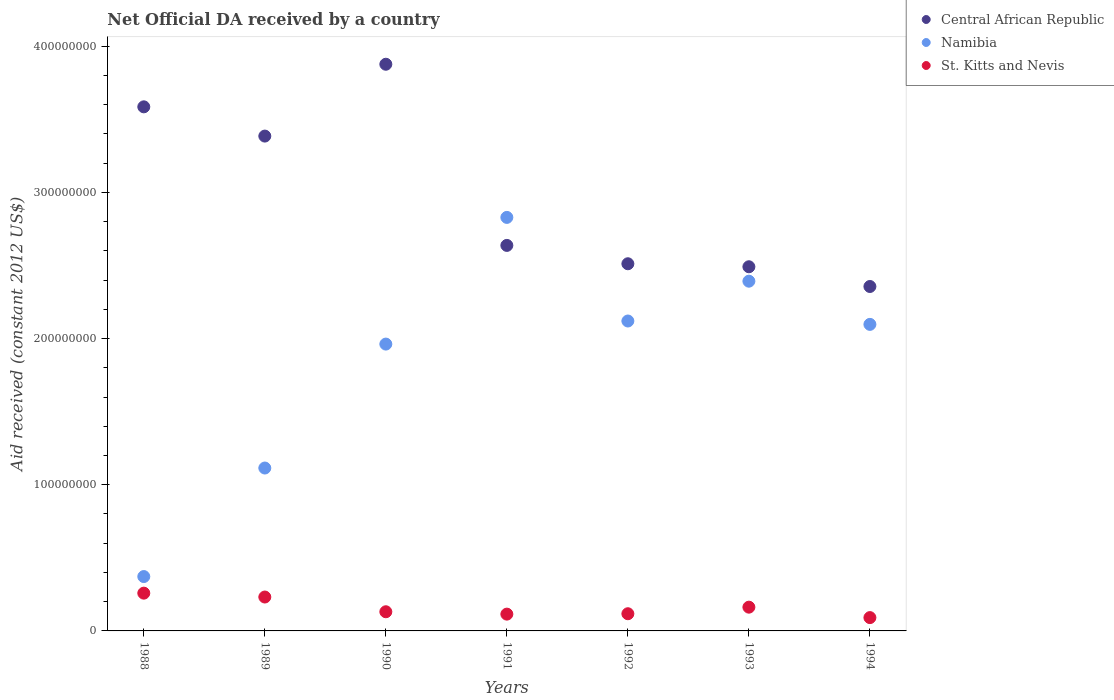Is the number of dotlines equal to the number of legend labels?
Your answer should be very brief. Yes. What is the net official development assistance aid received in Central African Republic in 1989?
Offer a very short reply. 3.39e+08. Across all years, what is the maximum net official development assistance aid received in Namibia?
Keep it short and to the point. 2.83e+08. Across all years, what is the minimum net official development assistance aid received in Central African Republic?
Offer a terse response. 2.36e+08. In which year was the net official development assistance aid received in Central African Republic minimum?
Make the answer very short. 1994. What is the total net official development assistance aid received in Namibia in the graph?
Offer a very short reply. 1.29e+09. What is the difference between the net official development assistance aid received in Namibia in 1989 and that in 1992?
Your answer should be very brief. -1.01e+08. What is the difference between the net official development assistance aid received in St. Kitts and Nevis in 1988 and the net official development assistance aid received in Central African Republic in 1992?
Offer a very short reply. -2.25e+08. What is the average net official development assistance aid received in Namibia per year?
Your answer should be very brief. 1.84e+08. In the year 1992, what is the difference between the net official development assistance aid received in St. Kitts and Nevis and net official development assistance aid received in Central African Republic?
Make the answer very short. -2.39e+08. In how many years, is the net official development assistance aid received in Central African Republic greater than 60000000 US$?
Give a very brief answer. 7. What is the ratio of the net official development assistance aid received in Central African Republic in 1988 to that in 1990?
Offer a terse response. 0.92. Is the net official development assistance aid received in Namibia in 1988 less than that in 1991?
Ensure brevity in your answer.  Yes. Is the difference between the net official development assistance aid received in St. Kitts and Nevis in 1988 and 1991 greater than the difference between the net official development assistance aid received in Central African Republic in 1988 and 1991?
Give a very brief answer. No. What is the difference between the highest and the second highest net official development assistance aid received in St. Kitts and Nevis?
Provide a succinct answer. 2.65e+06. What is the difference between the highest and the lowest net official development assistance aid received in Namibia?
Your answer should be very brief. 2.46e+08. Does the net official development assistance aid received in Namibia monotonically increase over the years?
Your response must be concise. No. Is the net official development assistance aid received in Namibia strictly greater than the net official development assistance aid received in Central African Republic over the years?
Provide a short and direct response. No. How many dotlines are there?
Provide a succinct answer. 3. How many years are there in the graph?
Provide a succinct answer. 7. Are the values on the major ticks of Y-axis written in scientific E-notation?
Your answer should be very brief. No. Does the graph contain any zero values?
Make the answer very short. No. Where does the legend appear in the graph?
Your answer should be very brief. Top right. How many legend labels are there?
Give a very brief answer. 3. How are the legend labels stacked?
Ensure brevity in your answer.  Vertical. What is the title of the graph?
Keep it short and to the point. Net Official DA received by a country. What is the label or title of the Y-axis?
Keep it short and to the point. Aid received (constant 2012 US$). What is the Aid received (constant 2012 US$) in Central African Republic in 1988?
Offer a terse response. 3.59e+08. What is the Aid received (constant 2012 US$) in Namibia in 1988?
Your answer should be compact. 3.72e+07. What is the Aid received (constant 2012 US$) in St. Kitts and Nevis in 1988?
Provide a short and direct response. 2.58e+07. What is the Aid received (constant 2012 US$) in Central African Republic in 1989?
Provide a short and direct response. 3.39e+08. What is the Aid received (constant 2012 US$) of Namibia in 1989?
Provide a succinct answer. 1.11e+08. What is the Aid received (constant 2012 US$) in St. Kitts and Nevis in 1989?
Offer a terse response. 2.32e+07. What is the Aid received (constant 2012 US$) in Central African Republic in 1990?
Provide a short and direct response. 3.88e+08. What is the Aid received (constant 2012 US$) in Namibia in 1990?
Offer a very short reply. 1.96e+08. What is the Aid received (constant 2012 US$) in St. Kitts and Nevis in 1990?
Your answer should be very brief. 1.31e+07. What is the Aid received (constant 2012 US$) of Central African Republic in 1991?
Provide a short and direct response. 2.64e+08. What is the Aid received (constant 2012 US$) of Namibia in 1991?
Your response must be concise. 2.83e+08. What is the Aid received (constant 2012 US$) of St. Kitts and Nevis in 1991?
Keep it short and to the point. 1.15e+07. What is the Aid received (constant 2012 US$) of Central African Republic in 1992?
Ensure brevity in your answer.  2.51e+08. What is the Aid received (constant 2012 US$) of Namibia in 1992?
Your answer should be very brief. 2.12e+08. What is the Aid received (constant 2012 US$) in St. Kitts and Nevis in 1992?
Provide a succinct answer. 1.18e+07. What is the Aid received (constant 2012 US$) of Central African Republic in 1993?
Your response must be concise. 2.49e+08. What is the Aid received (constant 2012 US$) of Namibia in 1993?
Provide a succinct answer. 2.39e+08. What is the Aid received (constant 2012 US$) of St. Kitts and Nevis in 1993?
Keep it short and to the point. 1.62e+07. What is the Aid received (constant 2012 US$) of Central African Republic in 1994?
Offer a very short reply. 2.36e+08. What is the Aid received (constant 2012 US$) of Namibia in 1994?
Give a very brief answer. 2.10e+08. What is the Aid received (constant 2012 US$) in St. Kitts and Nevis in 1994?
Your response must be concise. 9.11e+06. Across all years, what is the maximum Aid received (constant 2012 US$) of Central African Republic?
Your answer should be compact. 3.88e+08. Across all years, what is the maximum Aid received (constant 2012 US$) of Namibia?
Keep it short and to the point. 2.83e+08. Across all years, what is the maximum Aid received (constant 2012 US$) of St. Kitts and Nevis?
Ensure brevity in your answer.  2.58e+07. Across all years, what is the minimum Aid received (constant 2012 US$) of Central African Republic?
Make the answer very short. 2.36e+08. Across all years, what is the minimum Aid received (constant 2012 US$) of Namibia?
Provide a short and direct response. 3.72e+07. Across all years, what is the minimum Aid received (constant 2012 US$) in St. Kitts and Nevis?
Offer a very short reply. 9.11e+06. What is the total Aid received (constant 2012 US$) of Central African Republic in the graph?
Provide a succinct answer. 2.08e+09. What is the total Aid received (constant 2012 US$) in Namibia in the graph?
Your answer should be very brief. 1.29e+09. What is the total Aid received (constant 2012 US$) in St. Kitts and Nevis in the graph?
Your answer should be very brief. 1.11e+08. What is the difference between the Aid received (constant 2012 US$) in Central African Republic in 1988 and that in 1989?
Provide a succinct answer. 2.00e+07. What is the difference between the Aid received (constant 2012 US$) in Namibia in 1988 and that in 1989?
Your response must be concise. -7.43e+07. What is the difference between the Aid received (constant 2012 US$) of St. Kitts and Nevis in 1988 and that in 1989?
Give a very brief answer. 2.65e+06. What is the difference between the Aid received (constant 2012 US$) of Central African Republic in 1988 and that in 1990?
Keep it short and to the point. -2.91e+07. What is the difference between the Aid received (constant 2012 US$) of Namibia in 1988 and that in 1990?
Offer a terse response. -1.59e+08. What is the difference between the Aid received (constant 2012 US$) of St. Kitts and Nevis in 1988 and that in 1990?
Keep it short and to the point. 1.27e+07. What is the difference between the Aid received (constant 2012 US$) of Central African Republic in 1988 and that in 1991?
Make the answer very short. 9.48e+07. What is the difference between the Aid received (constant 2012 US$) in Namibia in 1988 and that in 1991?
Ensure brevity in your answer.  -2.46e+08. What is the difference between the Aid received (constant 2012 US$) of St. Kitts and Nevis in 1988 and that in 1991?
Ensure brevity in your answer.  1.44e+07. What is the difference between the Aid received (constant 2012 US$) of Central African Republic in 1988 and that in 1992?
Give a very brief answer. 1.07e+08. What is the difference between the Aid received (constant 2012 US$) in Namibia in 1988 and that in 1992?
Your answer should be compact. -1.75e+08. What is the difference between the Aid received (constant 2012 US$) of St. Kitts and Nevis in 1988 and that in 1992?
Give a very brief answer. 1.41e+07. What is the difference between the Aid received (constant 2012 US$) in Central African Republic in 1988 and that in 1993?
Offer a terse response. 1.09e+08. What is the difference between the Aid received (constant 2012 US$) of Namibia in 1988 and that in 1993?
Your answer should be very brief. -2.02e+08. What is the difference between the Aid received (constant 2012 US$) in St. Kitts and Nevis in 1988 and that in 1993?
Your answer should be compact. 9.59e+06. What is the difference between the Aid received (constant 2012 US$) of Central African Republic in 1988 and that in 1994?
Offer a terse response. 1.23e+08. What is the difference between the Aid received (constant 2012 US$) of Namibia in 1988 and that in 1994?
Offer a very short reply. -1.73e+08. What is the difference between the Aid received (constant 2012 US$) of St. Kitts and Nevis in 1988 and that in 1994?
Your answer should be compact. 1.67e+07. What is the difference between the Aid received (constant 2012 US$) in Central African Republic in 1989 and that in 1990?
Offer a very short reply. -4.92e+07. What is the difference between the Aid received (constant 2012 US$) in Namibia in 1989 and that in 1990?
Provide a short and direct response. -8.48e+07. What is the difference between the Aid received (constant 2012 US$) in St. Kitts and Nevis in 1989 and that in 1990?
Provide a short and direct response. 1.01e+07. What is the difference between the Aid received (constant 2012 US$) of Central African Republic in 1989 and that in 1991?
Offer a terse response. 7.48e+07. What is the difference between the Aid received (constant 2012 US$) in Namibia in 1989 and that in 1991?
Provide a short and direct response. -1.71e+08. What is the difference between the Aid received (constant 2012 US$) in St. Kitts and Nevis in 1989 and that in 1991?
Make the answer very short. 1.17e+07. What is the difference between the Aid received (constant 2012 US$) of Central African Republic in 1989 and that in 1992?
Offer a very short reply. 8.74e+07. What is the difference between the Aid received (constant 2012 US$) in Namibia in 1989 and that in 1992?
Your answer should be compact. -1.01e+08. What is the difference between the Aid received (constant 2012 US$) in St. Kitts and Nevis in 1989 and that in 1992?
Provide a short and direct response. 1.14e+07. What is the difference between the Aid received (constant 2012 US$) of Central African Republic in 1989 and that in 1993?
Provide a succinct answer. 8.94e+07. What is the difference between the Aid received (constant 2012 US$) in Namibia in 1989 and that in 1993?
Provide a short and direct response. -1.28e+08. What is the difference between the Aid received (constant 2012 US$) of St. Kitts and Nevis in 1989 and that in 1993?
Offer a very short reply. 6.94e+06. What is the difference between the Aid received (constant 2012 US$) of Central African Republic in 1989 and that in 1994?
Offer a terse response. 1.03e+08. What is the difference between the Aid received (constant 2012 US$) in Namibia in 1989 and that in 1994?
Your response must be concise. -9.83e+07. What is the difference between the Aid received (constant 2012 US$) of St. Kitts and Nevis in 1989 and that in 1994?
Keep it short and to the point. 1.41e+07. What is the difference between the Aid received (constant 2012 US$) of Central African Republic in 1990 and that in 1991?
Ensure brevity in your answer.  1.24e+08. What is the difference between the Aid received (constant 2012 US$) of Namibia in 1990 and that in 1991?
Your answer should be compact. -8.67e+07. What is the difference between the Aid received (constant 2012 US$) in St. Kitts and Nevis in 1990 and that in 1991?
Provide a succinct answer. 1.62e+06. What is the difference between the Aid received (constant 2012 US$) of Central African Republic in 1990 and that in 1992?
Your answer should be very brief. 1.36e+08. What is the difference between the Aid received (constant 2012 US$) of Namibia in 1990 and that in 1992?
Offer a very short reply. -1.58e+07. What is the difference between the Aid received (constant 2012 US$) of St. Kitts and Nevis in 1990 and that in 1992?
Offer a terse response. 1.35e+06. What is the difference between the Aid received (constant 2012 US$) in Central African Republic in 1990 and that in 1993?
Your answer should be compact. 1.39e+08. What is the difference between the Aid received (constant 2012 US$) of Namibia in 1990 and that in 1993?
Your response must be concise. -4.30e+07. What is the difference between the Aid received (constant 2012 US$) in St. Kitts and Nevis in 1990 and that in 1993?
Give a very brief answer. -3.14e+06. What is the difference between the Aid received (constant 2012 US$) in Central African Republic in 1990 and that in 1994?
Offer a terse response. 1.52e+08. What is the difference between the Aid received (constant 2012 US$) in Namibia in 1990 and that in 1994?
Keep it short and to the point. -1.35e+07. What is the difference between the Aid received (constant 2012 US$) of St. Kitts and Nevis in 1990 and that in 1994?
Keep it short and to the point. 4.00e+06. What is the difference between the Aid received (constant 2012 US$) of Central African Republic in 1991 and that in 1992?
Your response must be concise. 1.26e+07. What is the difference between the Aid received (constant 2012 US$) of Namibia in 1991 and that in 1992?
Give a very brief answer. 7.09e+07. What is the difference between the Aid received (constant 2012 US$) in Central African Republic in 1991 and that in 1993?
Provide a short and direct response. 1.46e+07. What is the difference between the Aid received (constant 2012 US$) in Namibia in 1991 and that in 1993?
Offer a terse response. 4.36e+07. What is the difference between the Aid received (constant 2012 US$) of St. Kitts and Nevis in 1991 and that in 1993?
Your answer should be very brief. -4.76e+06. What is the difference between the Aid received (constant 2012 US$) in Central African Republic in 1991 and that in 1994?
Your response must be concise. 2.81e+07. What is the difference between the Aid received (constant 2012 US$) of Namibia in 1991 and that in 1994?
Ensure brevity in your answer.  7.32e+07. What is the difference between the Aid received (constant 2012 US$) in St. Kitts and Nevis in 1991 and that in 1994?
Keep it short and to the point. 2.38e+06. What is the difference between the Aid received (constant 2012 US$) of Central African Republic in 1992 and that in 1993?
Keep it short and to the point. 2.06e+06. What is the difference between the Aid received (constant 2012 US$) in Namibia in 1992 and that in 1993?
Offer a terse response. -2.72e+07. What is the difference between the Aid received (constant 2012 US$) of St. Kitts and Nevis in 1992 and that in 1993?
Your answer should be very brief. -4.49e+06. What is the difference between the Aid received (constant 2012 US$) in Central African Republic in 1992 and that in 1994?
Keep it short and to the point. 1.56e+07. What is the difference between the Aid received (constant 2012 US$) in Namibia in 1992 and that in 1994?
Offer a terse response. 2.31e+06. What is the difference between the Aid received (constant 2012 US$) of St. Kitts and Nevis in 1992 and that in 1994?
Your answer should be compact. 2.65e+06. What is the difference between the Aid received (constant 2012 US$) of Central African Republic in 1993 and that in 1994?
Offer a terse response. 1.35e+07. What is the difference between the Aid received (constant 2012 US$) of Namibia in 1993 and that in 1994?
Your response must be concise. 2.96e+07. What is the difference between the Aid received (constant 2012 US$) of St. Kitts and Nevis in 1993 and that in 1994?
Give a very brief answer. 7.14e+06. What is the difference between the Aid received (constant 2012 US$) in Central African Republic in 1988 and the Aid received (constant 2012 US$) in Namibia in 1989?
Make the answer very short. 2.47e+08. What is the difference between the Aid received (constant 2012 US$) in Central African Republic in 1988 and the Aid received (constant 2012 US$) in St. Kitts and Nevis in 1989?
Provide a short and direct response. 3.35e+08. What is the difference between the Aid received (constant 2012 US$) in Namibia in 1988 and the Aid received (constant 2012 US$) in St. Kitts and Nevis in 1989?
Provide a succinct answer. 1.40e+07. What is the difference between the Aid received (constant 2012 US$) of Central African Republic in 1988 and the Aid received (constant 2012 US$) of Namibia in 1990?
Your response must be concise. 1.62e+08. What is the difference between the Aid received (constant 2012 US$) in Central African Republic in 1988 and the Aid received (constant 2012 US$) in St. Kitts and Nevis in 1990?
Offer a terse response. 3.45e+08. What is the difference between the Aid received (constant 2012 US$) in Namibia in 1988 and the Aid received (constant 2012 US$) in St. Kitts and Nevis in 1990?
Give a very brief answer. 2.41e+07. What is the difference between the Aid received (constant 2012 US$) in Central African Republic in 1988 and the Aid received (constant 2012 US$) in Namibia in 1991?
Offer a terse response. 7.56e+07. What is the difference between the Aid received (constant 2012 US$) of Central African Republic in 1988 and the Aid received (constant 2012 US$) of St. Kitts and Nevis in 1991?
Your answer should be compact. 3.47e+08. What is the difference between the Aid received (constant 2012 US$) of Namibia in 1988 and the Aid received (constant 2012 US$) of St. Kitts and Nevis in 1991?
Provide a succinct answer. 2.57e+07. What is the difference between the Aid received (constant 2012 US$) in Central African Republic in 1988 and the Aid received (constant 2012 US$) in Namibia in 1992?
Offer a very short reply. 1.47e+08. What is the difference between the Aid received (constant 2012 US$) in Central African Republic in 1988 and the Aid received (constant 2012 US$) in St. Kitts and Nevis in 1992?
Make the answer very short. 3.47e+08. What is the difference between the Aid received (constant 2012 US$) in Namibia in 1988 and the Aid received (constant 2012 US$) in St. Kitts and Nevis in 1992?
Give a very brief answer. 2.54e+07. What is the difference between the Aid received (constant 2012 US$) of Central African Republic in 1988 and the Aid received (constant 2012 US$) of Namibia in 1993?
Keep it short and to the point. 1.19e+08. What is the difference between the Aid received (constant 2012 US$) in Central African Republic in 1988 and the Aid received (constant 2012 US$) in St. Kitts and Nevis in 1993?
Ensure brevity in your answer.  3.42e+08. What is the difference between the Aid received (constant 2012 US$) of Namibia in 1988 and the Aid received (constant 2012 US$) of St. Kitts and Nevis in 1993?
Keep it short and to the point. 2.09e+07. What is the difference between the Aid received (constant 2012 US$) of Central African Republic in 1988 and the Aid received (constant 2012 US$) of Namibia in 1994?
Keep it short and to the point. 1.49e+08. What is the difference between the Aid received (constant 2012 US$) in Central African Republic in 1988 and the Aid received (constant 2012 US$) in St. Kitts and Nevis in 1994?
Make the answer very short. 3.49e+08. What is the difference between the Aid received (constant 2012 US$) in Namibia in 1988 and the Aid received (constant 2012 US$) in St. Kitts and Nevis in 1994?
Offer a very short reply. 2.81e+07. What is the difference between the Aid received (constant 2012 US$) in Central African Republic in 1989 and the Aid received (constant 2012 US$) in Namibia in 1990?
Your answer should be compact. 1.42e+08. What is the difference between the Aid received (constant 2012 US$) in Central African Republic in 1989 and the Aid received (constant 2012 US$) in St. Kitts and Nevis in 1990?
Give a very brief answer. 3.25e+08. What is the difference between the Aid received (constant 2012 US$) in Namibia in 1989 and the Aid received (constant 2012 US$) in St. Kitts and Nevis in 1990?
Give a very brief answer. 9.83e+07. What is the difference between the Aid received (constant 2012 US$) in Central African Republic in 1989 and the Aid received (constant 2012 US$) in Namibia in 1991?
Provide a short and direct response. 5.56e+07. What is the difference between the Aid received (constant 2012 US$) in Central African Republic in 1989 and the Aid received (constant 2012 US$) in St. Kitts and Nevis in 1991?
Provide a succinct answer. 3.27e+08. What is the difference between the Aid received (constant 2012 US$) of Namibia in 1989 and the Aid received (constant 2012 US$) of St. Kitts and Nevis in 1991?
Provide a succinct answer. 1.00e+08. What is the difference between the Aid received (constant 2012 US$) of Central African Republic in 1989 and the Aid received (constant 2012 US$) of Namibia in 1992?
Provide a short and direct response. 1.27e+08. What is the difference between the Aid received (constant 2012 US$) in Central African Republic in 1989 and the Aid received (constant 2012 US$) in St. Kitts and Nevis in 1992?
Provide a short and direct response. 3.27e+08. What is the difference between the Aid received (constant 2012 US$) of Namibia in 1989 and the Aid received (constant 2012 US$) of St. Kitts and Nevis in 1992?
Provide a succinct answer. 9.97e+07. What is the difference between the Aid received (constant 2012 US$) of Central African Republic in 1989 and the Aid received (constant 2012 US$) of Namibia in 1993?
Give a very brief answer. 9.93e+07. What is the difference between the Aid received (constant 2012 US$) in Central African Republic in 1989 and the Aid received (constant 2012 US$) in St. Kitts and Nevis in 1993?
Your answer should be very brief. 3.22e+08. What is the difference between the Aid received (constant 2012 US$) in Namibia in 1989 and the Aid received (constant 2012 US$) in St. Kitts and Nevis in 1993?
Provide a succinct answer. 9.52e+07. What is the difference between the Aid received (constant 2012 US$) of Central African Republic in 1989 and the Aid received (constant 2012 US$) of Namibia in 1994?
Offer a very short reply. 1.29e+08. What is the difference between the Aid received (constant 2012 US$) of Central African Republic in 1989 and the Aid received (constant 2012 US$) of St. Kitts and Nevis in 1994?
Provide a succinct answer. 3.29e+08. What is the difference between the Aid received (constant 2012 US$) in Namibia in 1989 and the Aid received (constant 2012 US$) in St. Kitts and Nevis in 1994?
Offer a very short reply. 1.02e+08. What is the difference between the Aid received (constant 2012 US$) in Central African Republic in 1990 and the Aid received (constant 2012 US$) in Namibia in 1991?
Keep it short and to the point. 1.05e+08. What is the difference between the Aid received (constant 2012 US$) of Central African Republic in 1990 and the Aid received (constant 2012 US$) of St. Kitts and Nevis in 1991?
Your answer should be very brief. 3.76e+08. What is the difference between the Aid received (constant 2012 US$) in Namibia in 1990 and the Aid received (constant 2012 US$) in St. Kitts and Nevis in 1991?
Offer a very short reply. 1.85e+08. What is the difference between the Aid received (constant 2012 US$) of Central African Republic in 1990 and the Aid received (constant 2012 US$) of Namibia in 1992?
Ensure brevity in your answer.  1.76e+08. What is the difference between the Aid received (constant 2012 US$) in Central African Republic in 1990 and the Aid received (constant 2012 US$) in St. Kitts and Nevis in 1992?
Your response must be concise. 3.76e+08. What is the difference between the Aid received (constant 2012 US$) in Namibia in 1990 and the Aid received (constant 2012 US$) in St. Kitts and Nevis in 1992?
Ensure brevity in your answer.  1.84e+08. What is the difference between the Aid received (constant 2012 US$) of Central African Republic in 1990 and the Aid received (constant 2012 US$) of Namibia in 1993?
Make the answer very short. 1.48e+08. What is the difference between the Aid received (constant 2012 US$) in Central African Republic in 1990 and the Aid received (constant 2012 US$) in St. Kitts and Nevis in 1993?
Make the answer very short. 3.71e+08. What is the difference between the Aid received (constant 2012 US$) in Namibia in 1990 and the Aid received (constant 2012 US$) in St. Kitts and Nevis in 1993?
Your answer should be very brief. 1.80e+08. What is the difference between the Aid received (constant 2012 US$) of Central African Republic in 1990 and the Aid received (constant 2012 US$) of Namibia in 1994?
Your answer should be compact. 1.78e+08. What is the difference between the Aid received (constant 2012 US$) in Central African Republic in 1990 and the Aid received (constant 2012 US$) in St. Kitts and Nevis in 1994?
Provide a succinct answer. 3.79e+08. What is the difference between the Aid received (constant 2012 US$) in Namibia in 1990 and the Aid received (constant 2012 US$) in St. Kitts and Nevis in 1994?
Give a very brief answer. 1.87e+08. What is the difference between the Aid received (constant 2012 US$) in Central African Republic in 1991 and the Aid received (constant 2012 US$) in Namibia in 1992?
Offer a terse response. 5.17e+07. What is the difference between the Aid received (constant 2012 US$) of Central African Republic in 1991 and the Aid received (constant 2012 US$) of St. Kitts and Nevis in 1992?
Your answer should be very brief. 2.52e+08. What is the difference between the Aid received (constant 2012 US$) of Namibia in 1991 and the Aid received (constant 2012 US$) of St. Kitts and Nevis in 1992?
Your answer should be very brief. 2.71e+08. What is the difference between the Aid received (constant 2012 US$) of Central African Republic in 1991 and the Aid received (constant 2012 US$) of Namibia in 1993?
Offer a terse response. 2.45e+07. What is the difference between the Aid received (constant 2012 US$) of Central African Republic in 1991 and the Aid received (constant 2012 US$) of St. Kitts and Nevis in 1993?
Provide a succinct answer. 2.48e+08. What is the difference between the Aid received (constant 2012 US$) in Namibia in 1991 and the Aid received (constant 2012 US$) in St. Kitts and Nevis in 1993?
Offer a very short reply. 2.67e+08. What is the difference between the Aid received (constant 2012 US$) of Central African Republic in 1991 and the Aid received (constant 2012 US$) of Namibia in 1994?
Offer a terse response. 5.40e+07. What is the difference between the Aid received (constant 2012 US$) in Central African Republic in 1991 and the Aid received (constant 2012 US$) in St. Kitts and Nevis in 1994?
Offer a terse response. 2.55e+08. What is the difference between the Aid received (constant 2012 US$) in Namibia in 1991 and the Aid received (constant 2012 US$) in St. Kitts and Nevis in 1994?
Provide a succinct answer. 2.74e+08. What is the difference between the Aid received (constant 2012 US$) of Central African Republic in 1992 and the Aid received (constant 2012 US$) of Namibia in 1993?
Give a very brief answer. 1.19e+07. What is the difference between the Aid received (constant 2012 US$) in Central African Republic in 1992 and the Aid received (constant 2012 US$) in St. Kitts and Nevis in 1993?
Provide a succinct answer. 2.35e+08. What is the difference between the Aid received (constant 2012 US$) in Namibia in 1992 and the Aid received (constant 2012 US$) in St. Kitts and Nevis in 1993?
Give a very brief answer. 1.96e+08. What is the difference between the Aid received (constant 2012 US$) of Central African Republic in 1992 and the Aid received (constant 2012 US$) of Namibia in 1994?
Ensure brevity in your answer.  4.15e+07. What is the difference between the Aid received (constant 2012 US$) of Central African Republic in 1992 and the Aid received (constant 2012 US$) of St. Kitts and Nevis in 1994?
Provide a short and direct response. 2.42e+08. What is the difference between the Aid received (constant 2012 US$) in Namibia in 1992 and the Aid received (constant 2012 US$) in St. Kitts and Nevis in 1994?
Make the answer very short. 2.03e+08. What is the difference between the Aid received (constant 2012 US$) in Central African Republic in 1993 and the Aid received (constant 2012 US$) in Namibia in 1994?
Your answer should be compact. 3.94e+07. What is the difference between the Aid received (constant 2012 US$) in Central African Republic in 1993 and the Aid received (constant 2012 US$) in St. Kitts and Nevis in 1994?
Your response must be concise. 2.40e+08. What is the difference between the Aid received (constant 2012 US$) in Namibia in 1993 and the Aid received (constant 2012 US$) in St. Kitts and Nevis in 1994?
Make the answer very short. 2.30e+08. What is the average Aid received (constant 2012 US$) in Central African Republic per year?
Keep it short and to the point. 2.98e+08. What is the average Aid received (constant 2012 US$) in Namibia per year?
Ensure brevity in your answer.  1.84e+08. What is the average Aid received (constant 2012 US$) of St. Kitts and Nevis per year?
Provide a succinct answer. 1.58e+07. In the year 1988, what is the difference between the Aid received (constant 2012 US$) in Central African Republic and Aid received (constant 2012 US$) in Namibia?
Provide a short and direct response. 3.21e+08. In the year 1988, what is the difference between the Aid received (constant 2012 US$) in Central African Republic and Aid received (constant 2012 US$) in St. Kitts and Nevis?
Provide a succinct answer. 3.33e+08. In the year 1988, what is the difference between the Aid received (constant 2012 US$) in Namibia and Aid received (constant 2012 US$) in St. Kitts and Nevis?
Give a very brief answer. 1.14e+07. In the year 1989, what is the difference between the Aid received (constant 2012 US$) in Central African Republic and Aid received (constant 2012 US$) in Namibia?
Keep it short and to the point. 2.27e+08. In the year 1989, what is the difference between the Aid received (constant 2012 US$) of Central African Republic and Aid received (constant 2012 US$) of St. Kitts and Nevis?
Ensure brevity in your answer.  3.15e+08. In the year 1989, what is the difference between the Aid received (constant 2012 US$) of Namibia and Aid received (constant 2012 US$) of St. Kitts and Nevis?
Make the answer very short. 8.83e+07. In the year 1990, what is the difference between the Aid received (constant 2012 US$) in Central African Republic and Aid received (constant 2012 US$) in Namibia?
Offer a terse response. 1.91e+08. In the year 1990, what is the difference between the Aid received (constant 2012 US$) of Central African Republic and Aid received (constant 2012 US$) of St. Kitts and Nevis?
Your response must be concise. 3.75e+08. In the year 1990, what is the difference between the Aid received (constant 2012 US$) of Namibia and Aid received (constant 2012 US$) of St. Kitts and Nevis?
Offer a terse response. 1.83e+08. In the year 1991, what is the difference between the Aid received (constant 2012 US$) of Central African Republic and Aid received (constant 2012 US$) of Namibia?
Give a very brief answer. -1.92e+07. In the year 1991, what is the difference between the Aid received (constant 2012 US$) in Central African Republic and Aid received (constant 2012 US$) in St. Kitts and Nevis?
Provide a succinct answer. 2.52e+08. In the year 1991, what is the difference between the Aid received (constant 2012 US$) in Namibia and Aid received (constant 2012 US$) in St. Kitts and Nevis?
Provide a short and direct response. 2.71e+08. In the year 1992, what is the difference between the Aid received (constant 2012 US$) in Central African Republic and Aid received (constant 2012 US$) in Namibia?
Your answer should be compact. 3.92e+07. In the year 1992, what is the difference between the Aid received (constant 2012 US$) in Central African Republic and Aid received (constant 2012 US$) in St. Kitts and Nevis?
Ensure brevity in your answer.  2.39e+08. In the year 1992, what is the difference between the Aid received (constant 2012 US$) of Namibia and Aid received (constant 2012 US$) of St. Kitts and Nevis?
Offer a terse response. 2.00e+08. In the year 1993, what is the difference between the Aid received (constant 2012 US$) of Central African Republic and Aid received (constant 2012 US$) of Namibia?
Provide a short and direct response. 9.87e+06. In the year 1993, what is the difference between the Aid received (constant 2012 US$) in Central African Republic and Aid received (constant 2012 US$) in St. Kitts and Nevis?
Provide a short and direct response. 2.33e+08. In the year 1993, what is the difference between the Aid received (constant 2012 US$) in Namibia and Aid received (constant 2012 US$) in St. Kitts and Nevis?
Make the answer very short. 2.23e+08. In the year 1994, what is the difference between the Aid received (constant 2012 US$) of Central African Republic and Aid received (constant 2012 US$) of Namibia?
Offer a terse response. 2.59e+07. In the year 1994, what is the difference between the Aid received (constant 2012 US$) of Central African Republic and Aid received (constant 2012 US$) of St. Kitts and Nevis?
Give a very brief answer. 2.27e+08. In the year 1994, what is the difference between the Aid received (constant 2012 US$) of Namibia and Aid received (constant 2012 US$) of St. Kitts and Nevis?
Your answer should be compact. 2.01e+08. What is the ratio of the Aid received (constant 2012 US$) of Central African Republic in 1988 to that in 1989?
Provide a short and direct response. 1.06. What is the ratio of the Aid received (constant 2012 US$) in Namibia in 1988 to that in 1989?
Provide a succinct answer. 0.33. What is the ratio of the Aid received (constant 2012 US$) in St. Kitts and Nevis in 1988 to that in 1989?
Provide a succinct answer. 1.11. What is the ratio of the Aid received (constant 2012 US$) in Central African Republic in 1988 to that in 1990?
Ensure brevity in your answer.  0.92. What is the ratio of the Aid received (constant 2012 US$) of Namibia in 1988 to that in 1990?
Make the answer very short. 0.19. What is the ratio of the Aid received (constant 2012 US$) in St. Kitts and Nevis in 1988 to that in 1990?
Offer a very short reply. 1.97. What is the ratio of the Aid received (constant 2012 US$) in Central African Republic in 1988 to that in 1991?
Your answer should be very brief. 1.36. What is the ratio of the Aid received (constant 2012 US$) of Namibia in 1988 to that in 1991?
Make the answer very short. 0.13. What is the ratio of the Aid received (constant 2012 US$) in St. Kitts and Nevis in 1988 to that in 1991?
Offer a very short reply. 2.25. What is the ratio of the Aid received (constant 2012 US$) of Central African Republic in 1988 to that in 1992?
Your answer should be very brief. 1.43. What is the ratio of the Aid received (constant 2012 US$) of Namibia in 1988 to that in 1992?
Your response must be concise. 0.18. What is the ratio of the Aid received (constant 2012 US$) in St. Kitts and Nevis in 1988 to that in 1992?
Your answer should be very brief. 2.2. What is the ratio of the Aid received (constant 2012 US$) in Central African Republic in 1988 to that in 1993?
Your response must be concise. 1.44. What is the ratio of the Aid received (constant 2012 US$) in Namibia in 1988 to that in 1993?
Give a very brief answer. 0.16. What is the ratio of the Aid received (constant 2012 US$) of St. Kitts and Nevis in 1988 to that in 1993?
Keep it short and to the point. 1.59. What is the ratio of the Aid received (constant 2012 US$) in Central African Republic in 1988 to that in 1994?
Give a very brief answer. 1.52. What is the ratio of the Aid received (constant 2012 US$) in Namibia in 1988 to that in 1994?
Make the answer very short. 0.18. What is the ratio of the Aid received (constant 2012 US$) in St. Kitts and Nevis in 1988 to that in 1994?
Make the answer very short. 2.84. What is the ratio of the Aid received (constant 2012 US$) of Central African Republic in 1989 to that in 1990?
Provide a short and direct response. 0.87. What is the ratio of the Aid received (constant 2012 US$) in Namibia in 1989 to that in 1990?
Keep it short and to the point. 0.57. What is the ratio of the Aid received (constant 2012 US$) of St. Kitts and Nevis in 1989 to that in 1990?
Offer a terse response. 1.77. What is the ratio of the Aid received (constant 2012 US$) of Central African Republic in 1989 to that in 1991?
Provide a succinct answer. 1.28. What is the ratio of the Aid received (constant 2012 US$) of Namibia in 1989 to that in 1991?
Ensure brevity in your answer.  0.39. What is the ratio of the Aid received (constant 2012 US$) in St. Kitts and Nevis in 1989 to that in 1991?
Make the answer very short. 2.02. What is the ratio of the Aid received (constant 2012 US$) in Central African Republic in 1989 to that in 1992?
Give a very brief answer. 1.35. What is the ratio of the Aid received (constant 2012 US$) of Namibia in 1989 to that in 1992?
Provide a succinct answer. 0.53. What is the ratio of the Aid received (constant 2012 US$) in St. Kitts and Nevis in 1989 to that in 1992?
Your answer should be very brief. 1.97. What is the ratio of the Aid received (constant 2012 US$) in Central African Republic in 1989 to that in 1993?
Keep it short and to the point. 1.36. What is the ratio of the Aid received (constant 2012 US$) in Namibia in 1989 to that in 1993?
Make the answer very short. 0.47. What is the ratio of the Aid received (constant 2012 US$) of St. Kitts and Nevis in 1989 to that in 1993?
Your answer should be compact. 1.43. What is the ratio of the Aid received (constant 2012 US$) in Central African Republic in 1989 to that in 1994?
Offer a very short reply. 1.44. What is the ratio of the Aid received (constant 2012 US$) of Namibia in 1989 to that in 1994?
Offer a terse response. 0.53. What is the ratio of the Aid received (constant 2012 US$) in St. Kitts and Nevis in 1989 to that in 1994?
Ensure brevity in your answer.  2.55. What is the ratio of the Aid received (constant 2012 US$) in Central African Republic in 1990 to that in 1991?
Ensure brevity in your answer.  1.47. What is the ratio of the Aid received (constant 2012 US$) in Namibia in 1990 to that in 1991?
Provide a short and direct response. 0.69. What is the ratio of the Aid received (constant 2012 US$) in St. Kitts and Nevis in 1990 to that in 1991?
Your answer should be very brief. 1.14. What is the ratio of the Aid received (constant 2012 US$) in Central African Republic in 1990 to that in 1992?
Offer a very short reply. 1.54. What is the ratio of the Aid received (constant 2012 US$) in Namibia in 1990 to that in 1992?
Ensure brevity in your answer.  0.93. What is the ratio of the Aid received (constant 2012 US$) in St. Kitts and Nevis in 1990 to that in 1992?
Your response must be concise. 1.11. What is the ratio of the Aid received (constant 2012 US$) in Central African Republic in 1990 to that in 1993?
Provide a succinct answer. 1.56. What is the ratio of the Aid received (constant 2012 US$) in Namibia in 1990 to that in 1993?
Provide a succinct answer. 0.82. What is the ratio of the Aid received (constant 2012 US$) of St. Kitts and Nevis in 1990 to that in 1993?
Your response must be concise. 0.81. What is the ratio of the Aid received (constant 2012 US$) in Central African Republic in 1990 to that in 1994?
Your response must be concise. 1.65. What is the ratio of the Aid received (constant 2012 US$) of Namibia in 1990 to that in 1994?
Keep it short and to the point. 0.94. What is the ratio of the Aid received (constant 2012 US$) of St. Kitts and Nevis in 1990 to that in 1994?
Your answer should be compact. 1.44. What is the ratio of the Aid received (constant 2012 US$) of Namibia in 1991 to that in 1992?
Make the answer very short. 1.33. What is the ratio of the Aid received (constant 2012 US$) in St. Kitts and Nevis in 1991 to that in 1992?
Offer a terse response. 0.98. What is the ratio of the Aid received (constant 2012 US$) of Central African Republic in 1991 to that in 1993?
Offer a terse response. 1.06. What is the ratio of the Aid received (constant 2012 US$) in Namibia in 1991 to that in 1993?
Make the answer very short. 1.18. What is the ratio of the Aid received (constant 2012 US$) of St. Kitts and Nevis in 1991 to that in 1993?
Your answer should be compact. 0.71. What is the ratio of the Aid received (constant 2012 US$) of Central African Republic in 1991 to that in 1994?
Make the answer very short. 1.12. What is the ratio of the Aid received (constant 2012 US$) in Namibia in 1991 to that in 1994?
Your response must be concise. 1.35. What is the ratio of the Aid received (constant 2012 US$) of St. Kitts and Nevis in 1991 to that in 1994?
Keep it short and to the point. 1.26. What is the ratio of the Aid received (constant 2012 US$) of Central African Republic in 1992 to that in 1993?
Offer a very short reply. 1.01. What is the ratio of the Aid received (constant 2012 US$) in Namibia in 1992 to that in 1993?
Ensure brevity in your answer.  0.89. What is the ratio of the Aid received (constant 2012 US$) of St. Kitts and Nevis in 1992 to that in 1993?
Keep it short and to the point. 0.72. What is the ratio of the Aid received (constant 2012 US$) of Central African Republic in 1992 to that in 1994?
Offer a terse response. 1.07. What is the ratio of the Aid received (constant 2012 US$) of Namibia in 1992 to that in 1994?
Your response must be concise. 1.01. What is the ratio of the Aid received (constant 2012 US$) of St. Kitts and Nevis in 1992 to that in 1994?
Keep it short and to the point. 1.29. What is the ratio of the Aid received (constant 2012 US$) in Central African Republic in 1993 to that in 1994?
Provide a short and direct response. 1.06. What is the ratio of the Aid received (constant 2012 US$) in Namibia in 1993 to that in 1994?
Offer a very short reply. 1.14. What is the ratio of the Aid received (constant 2012 US$) of St. Kitts and Nevis in 1993 to that in 1994?
Your answer should be compact. 1.78. What is the difference between the highest and the second highest Aid received (constant 2012 US$) of Central African Republic?
Provide a short and direct response. 2.91e+07. What is the difference between the highest and the second highest Aid received (constant 2012 US$) in Namibia?
Ensure brevity in your answer.  4.36e+07. What is the difference between the highest and the second highest Aid received (constant 2012 US$) in St. Kitts and Nevis?
Provide a succinct answer. 2.65e+06. What is the difference between the highest and the lowest Aid received (constant 2012 US$) of Central African Republic?
Your answer should be very brief. 1.52e+08. What is the difference between the highest and the lowest Aid received (constant 2012 US$) of Namibia?
Your response must be concise. 2.46e+08. What is the difference between the highest and the lowest Aid received (constant 2012 US$) in St. Kitts and Nevis?
Keep it short and to the point. 1.67e+07. 